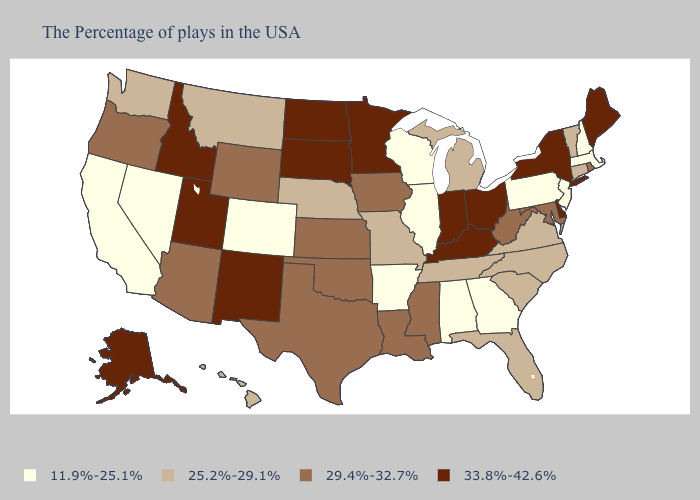Does South Dakota have the highest value in the USA?
Answer briefly. Yes. What is the lowest value in the MidWest?
Give a very brief answer. 11.9%-25.1%. Name the states that have a value in the range 25.2%-29.1%?
Be succinct. Vermont, Connecticut, Virginia, North Carolina, South Carolina, Florida, Michigan, Tennessee, Missouri, Nebraska, Montana, Washington, Hawaii. How many symbols are there in the legend?
Give a very brief answer. 4. Name the states that have a value in the range 29.4%-32.7%?
Short answer required. Rhode Island, Maryland, West Virginia, Mississippi, Louisiana, Iowa, Kansas, Oklahoma, Texas, Wyoming, Arizona, Oregon. Does Alabama have the lowest value in the USA?
Be succinct. Yes. Does Iowa have the lowest value in the USA?
Give a very brief answer. No. What is the value of Ohio?
Write a very short answer. 33.8%-42.6%. Which states have the highest value in the USA?
Write a very short answer. Maine, New York, Delaware, Ohio, Kentucky, Indiana, Minnesota, South Dakota, North Dakota, New Mexico, Utah, Idaho, Alaska. Name the states that have a value in the range 25.2%-29.1%?
Answer briefly. Vermont, Connecticut, Virginia, North Carolina, South Carolina, Florida, Michigan, Tennessee, Missouri, Nebraska, Montana, Washington, Hawaii. Which states have the highest value in the USA?
Keep it brief. Maine, New York, Delaware, Ohio, Kentucky, Indiana, Minnesota, South Dakota, North Dakota, New Mexico, Utah, Idaho, Alaska. Is the legend a continuous bar?
Short answer required. No. Name the states that have a value in the range 11.9%-25.1%?
Give a very brief answer. Massachusetts, New Hampshire, New Jersey, Pennsylvania, Georgia, Alabama, Wisconsin, Illinois, Arkansas, Colorado, Nevada, California. What is the value of Utah?
Give a very brief answer. 33.8%-42.6%. 